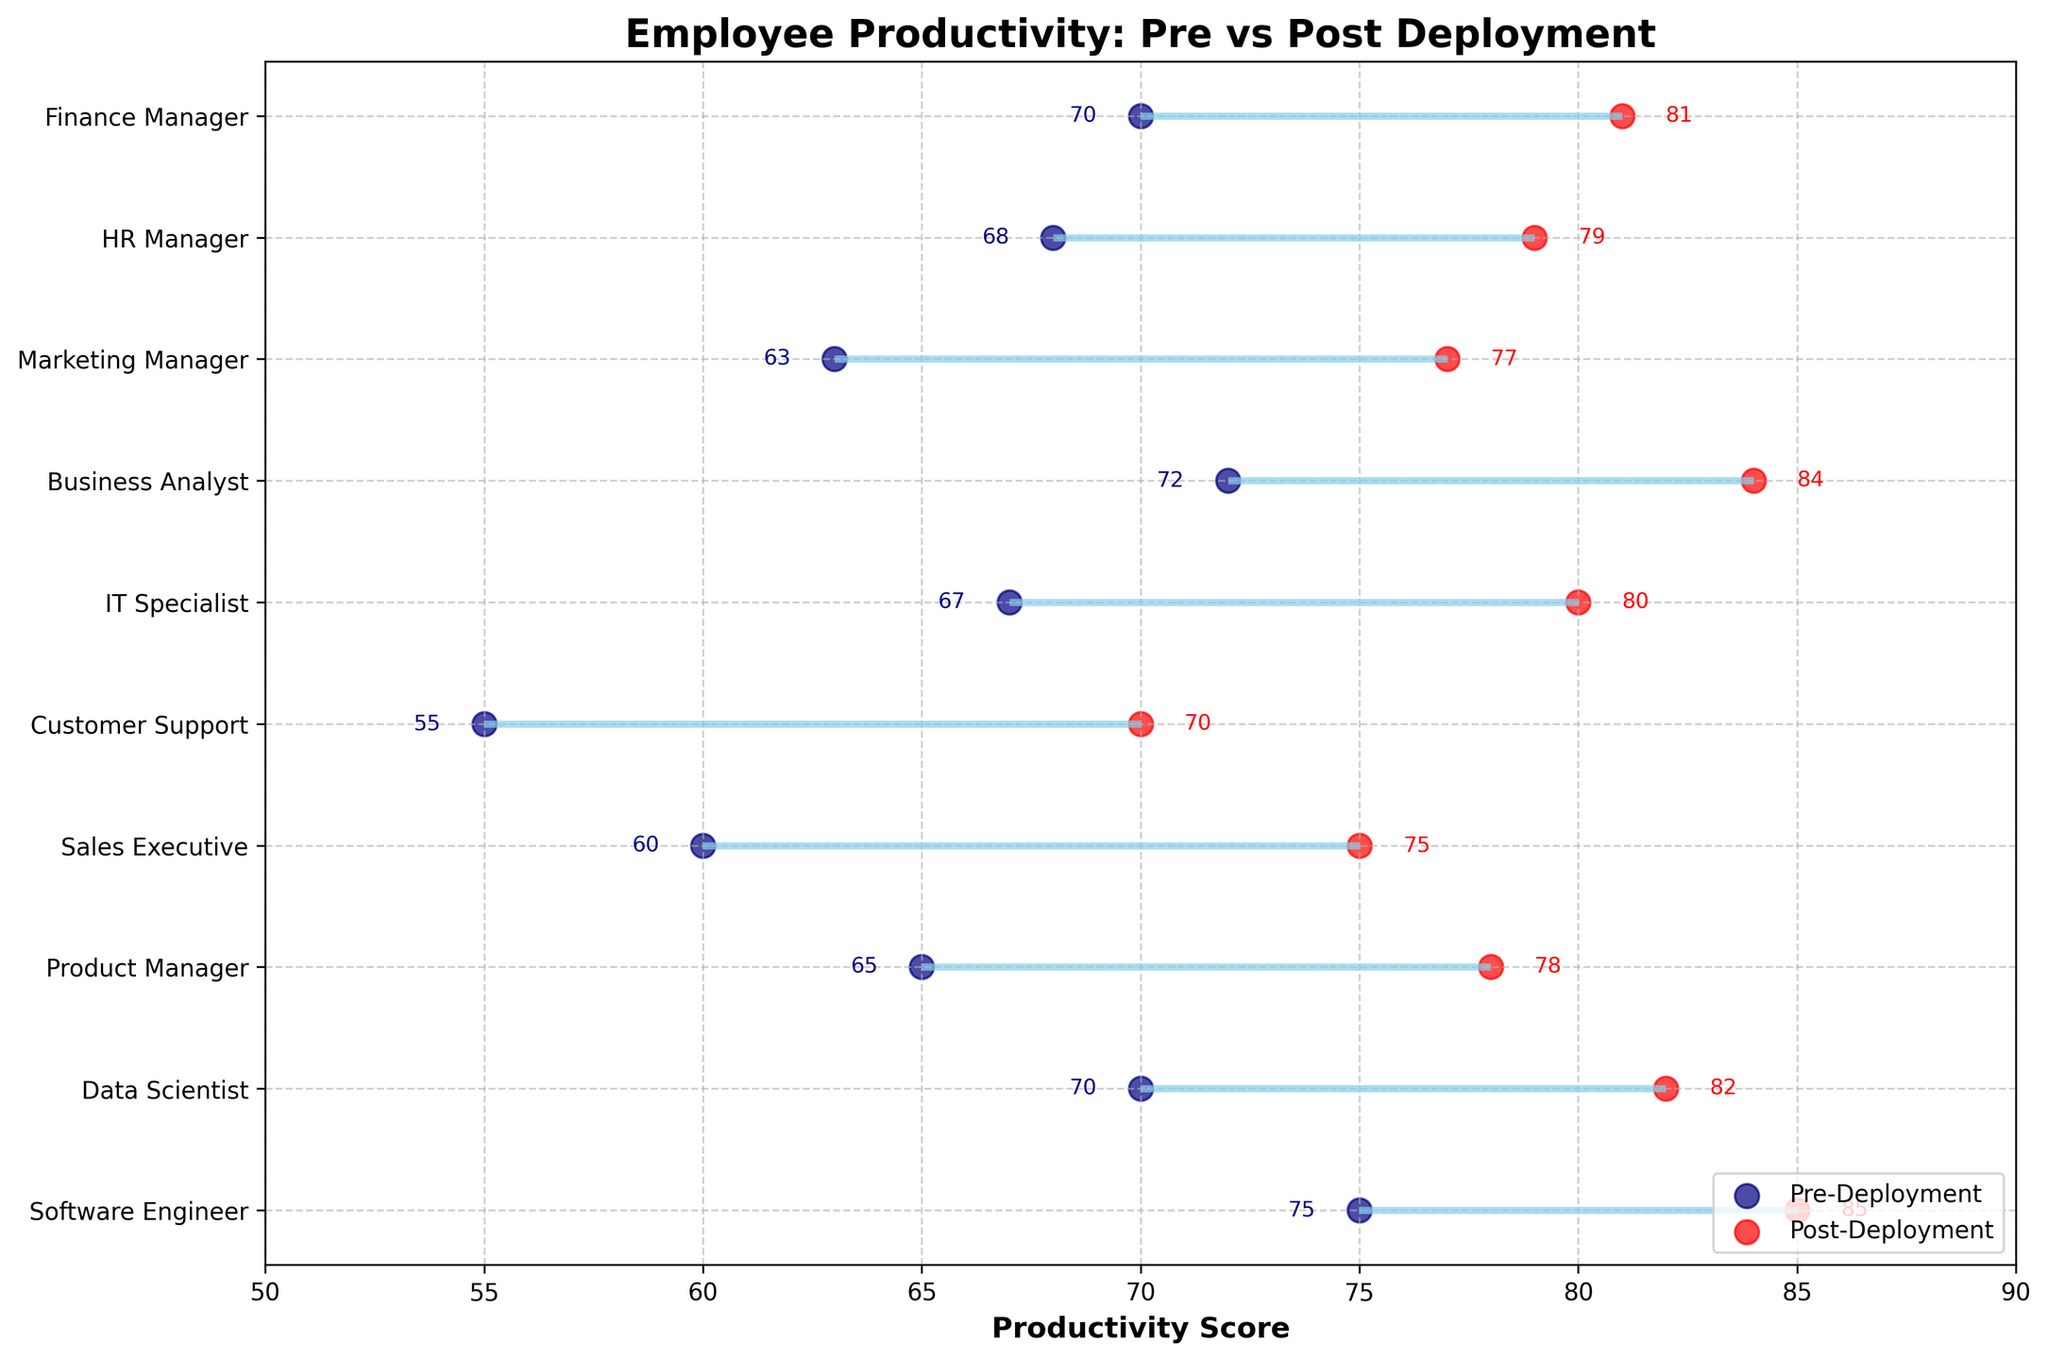What is the title of the figure? The title of the figure can be found at the top, indicating the main focus. The title here is "Employee Productivity: Pre vs Post Deployment".
Answer: Employee Productivity: Pre vs Post Deployment Which job role had the highest increase in productivity? You need to find the job role with the most considerable difference between pre- and post-deployment productivity scores by checking the end points of each dumbbell line. The Data Scientist had the highest increase with an increase from 70 to 82.
Answer: Data Scientist What is the productivity score of the Sales Executive role post-deployment? Look at the point labeled "Sales Executive" on the y-axis and find the end of the red line. The score is shown next to the red dot at the end, which is 75.
Answer: 75 Which job role had the lowest productivity score pre-deployment? Among all the starting points (navy dots), find the smallest value. The Customer Support role had the lowest productivity score pre-deployment with a score of 55.
Answer: Customer Support What is the average productivity of the HR Manager before and after the deployment? To find the average, sum the pre- and post-deployment productivity scores of the HR Manager and divide by 2. (68 + 79) / 2 = 73.5
Answer: 73.5 Which job role experienced the smallest increase in productivity? You need to find the job role with the smallest difference between pre- and post-deployment productivity scores by looking at the length of the dumbbell lines. The HR Manager had the smallest increase from 68 to 79, which is an increase of 11.
Answer: HR Manager How many job roles had a post-deployment productivity score of 80 or higher? Count how many red dots are at 80 or higher by looking at the post-deployment scores. There are four roles: Software Engineer, Data Scientist, IT Specialist, and Business Analyst.
Answer: 4 Which two job roles had the same pre-deployment productivity score? Look for matching values among the pre-deployment scores. Both Data Scientist and Finance Manager had the same pre-deployment productivity score of 70.
Answer: Data Scientist and Finance Manager What is the difference between the pre- and post-deployment productivity scores of the Product Manager? Subtract the pre-deployment score from the post-deployment score for the Product Manager. (78 - 65) = 13
Answer: 13 Is there any job role where the post-deployment productivity score is exactly 85? Review the post-deployment scores for a value of 85 and indicate the job role associated. The Software Engineer has a post-deployment productivity score of exactly 85.
Answer: Software Engineer 